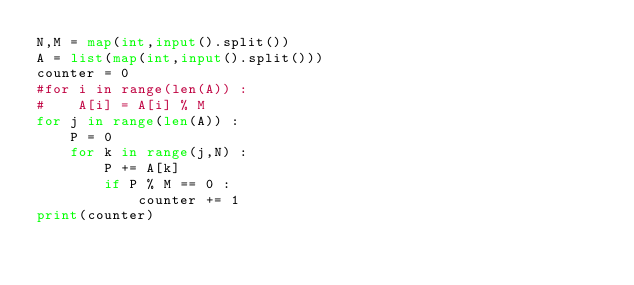Convert code to text. <code><loc_0><loc_0><loc_500><loc_500><_Python_>N,M = map(int,input().split())
A = list(map(int,input().split()))
counter = 0
#for i in range(len(A)) :
#    A[i] = A[i] % M
for j in range(len(A)) :
    P = 0
    for k in range(j,N) :
        P += A[k]
        if P % M == 0 :
            counter += 1
print(counter)

</code> 